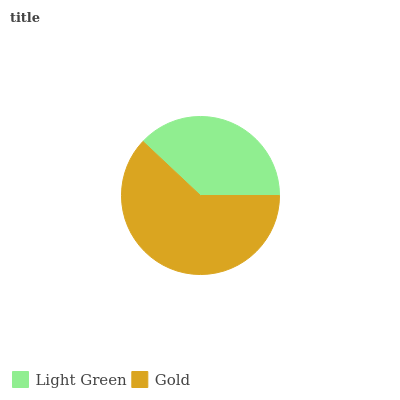Is Light Green the minimum?
Answer yes or no. Yes. Is Gold the maximum?
Answer yes or no. Yes. Is Gold the minimum?
Answer yes or no. No. Is Gold greater than Light Green?
Answer yes or no. Yes. Is Light Green less than Gold?
Answer yes or no. Yes. Is Light Green greater than Gold?
Answer yes or no. No. Is Gold less than Light Green?
Answer yes or no. No. Is Gold the high median?
Answer yes or no. Yes. Is Light Green the low median?
Answer yes or no. Yes. Is Light Green the high median?
Answer yes or no. No. Is Gold the low median?
Answer yes or no. No. 